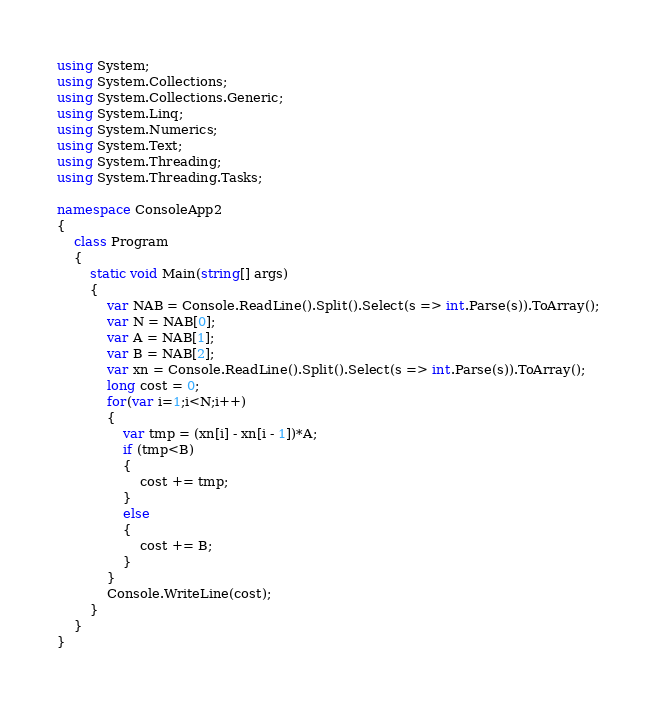<code> <loc_0><loc_0><loc_500><loc_500><_C#_>using System;
using System.Collections;
using System.Collections.Generic;
using System.Linq;
using System.Numerics;
using System.Text;
using System.Threading;
using System.Threading.Tasks;

namespace ConsoleApp2
{
    class Program
    {
        static void Main(string[] args)
        {
            var NAB = Console.ReadLine().Split().Select(s => int.Parse(s)).ToArray();
            var N = NAB[0];
            var A = NAB[1];
            var B = NAB[2];
            var xn = Console.ReadLine().Split().Select(s => int.Parse(s)).ToArray();
            long cost = 0;
            for(var i=1;i<N;i++)
            {
                var tmp = (xn[i] - xn[i - 1])*A;
                if (tmp<B)
                {
                    cost += tmp;
                }
                else
                {
                    cost += B;
                }
            }
            Console.WriteLine(cost);
        }
    }
}</code> 